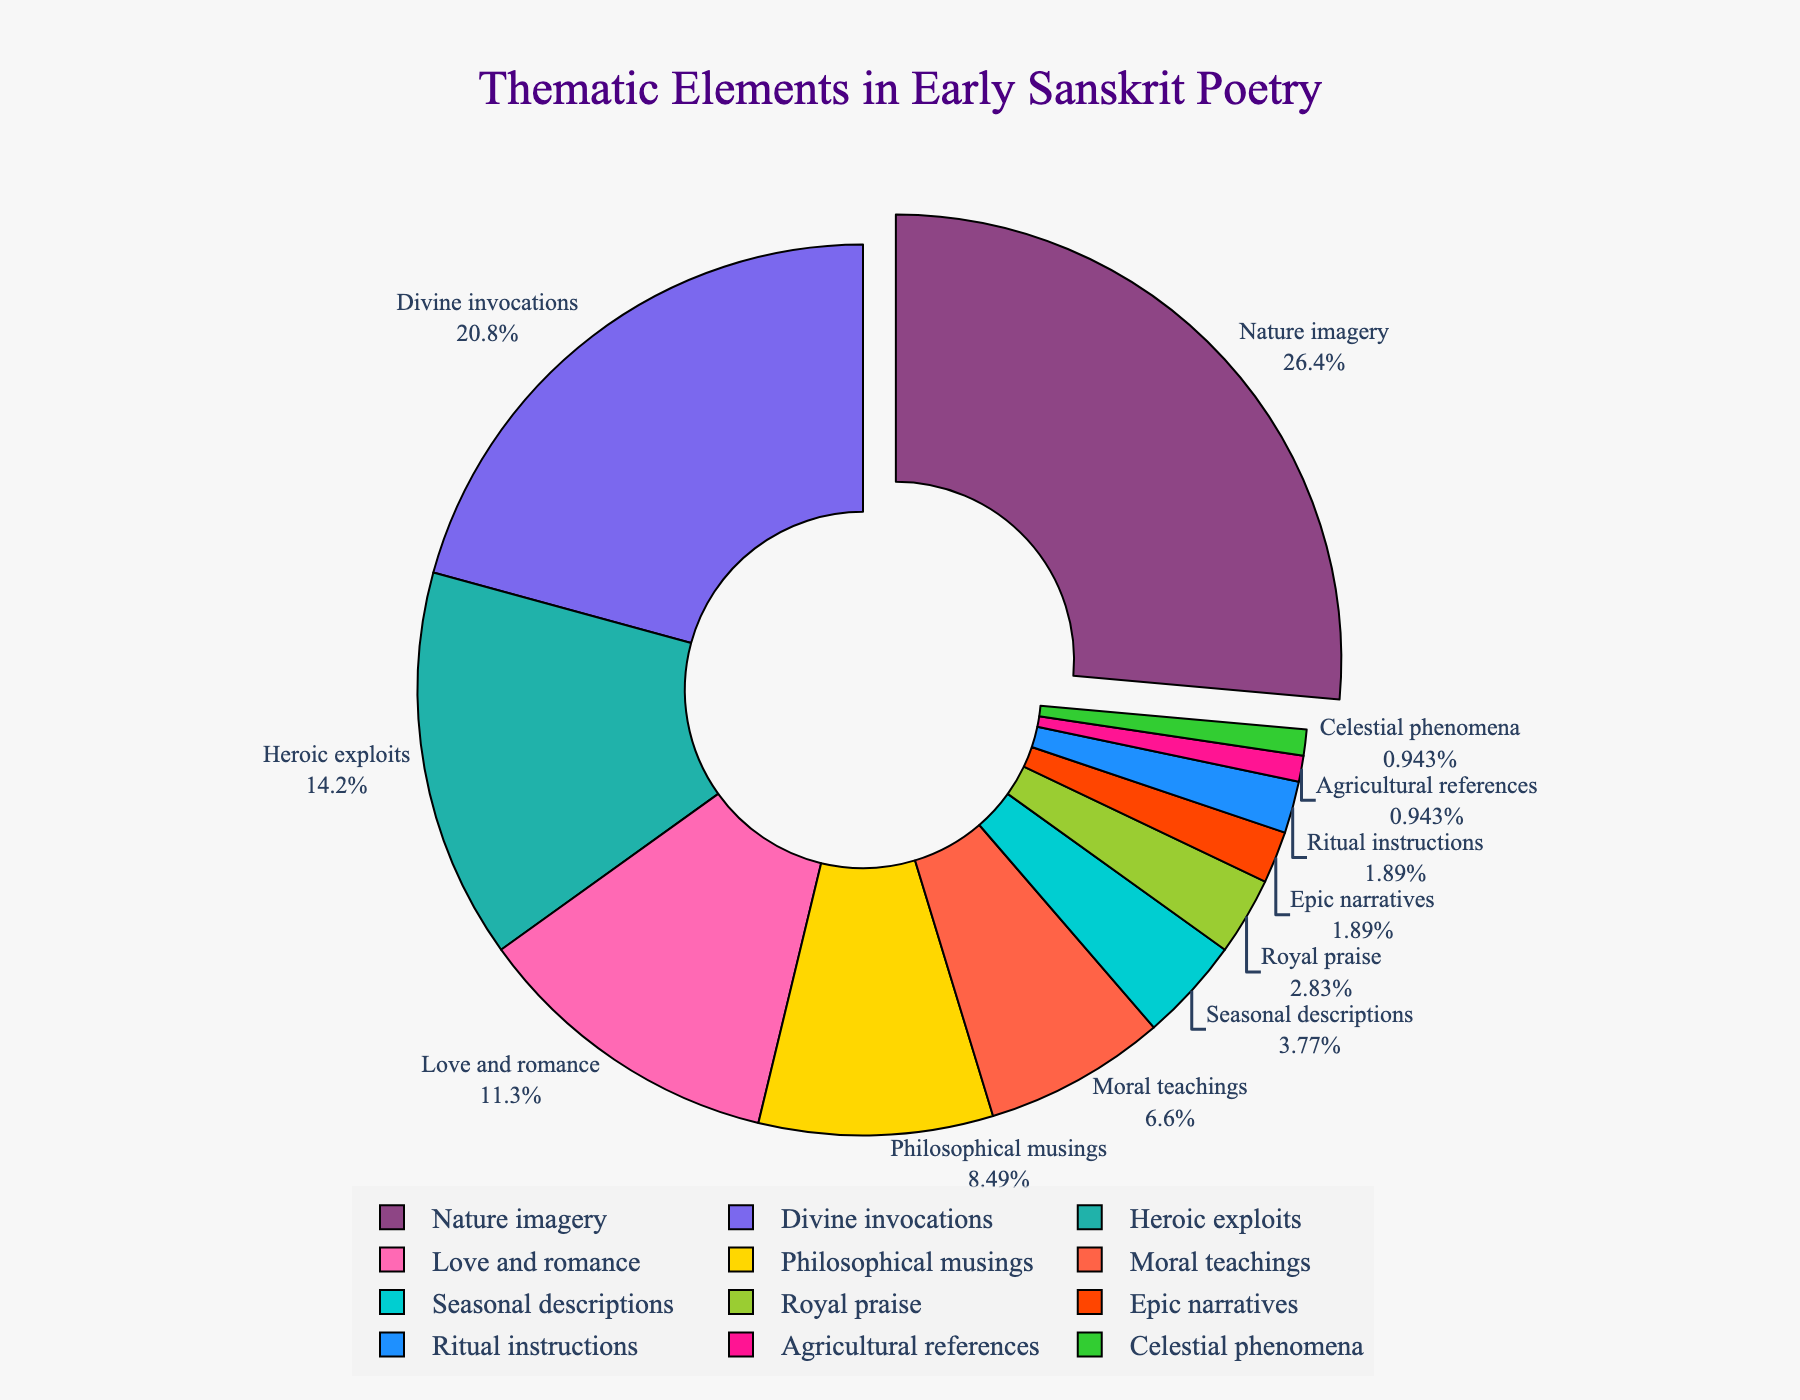What is the most frequently occurring theme in early Sanskrit poetry? The chart shows the thematic elements in early Sanskrit poetry by percentage. By looking at the largest segment, we can identify the most frequently occurring theme. Nature imagery has the largest segment at 28%.
Answer: Nature imagery What is the combined percentage of Divine invocations and Heroic exploits themes? To determine the combined percentage, add the percentages of Divine invocations (22%) and Heroic exploits (15%). Therefore, 22% + 15% = 37%.
Answer: 37% Which theme is represented by the smallest slice in the pie chart? The chart visually represents each thematic element. The smallest slice represents the themes of Agricultural references and Celestial phenomena, each at 1%.
Answer: Agricultural references and Celestial phenomena How much larger is the percentage of Love and romance compared to Royal praise? Compare their percentages: Love and romance is 12%, and Royal praise is 3%. To find how much larger Love and romance is, subtract the percentage of Royal praise from Love and romance: 12% - 3% = 9%.
Answer: 9% What is the difference in percentage between Moral teachings and Philosophical musings? Compare their percentages: Philosophical musings (9%) and Moral teachings (7%). The difference can be calculated as 9% - 7% = 2%.
Answer: 2% Which themes occupy less than 5% of the pie chart individually? The themes with less than 5% are those represented by smaller slices: Seasonal descriptions (4%), Royal praise (3%), Epic narratives (2%), Ritual instructions (2%), Agricultural references (1%), and Celestial phenomena (1%).
Answer: Seasonal descriptions, Royal praise, Epic narratives, Ritual instructions, Agricultural references, Celestial phenomena What is the visual significance of Nature imagery in the chart? In the pie chart, Nature imagery is visually emphasized by being pulled out more than the other slices, indicating its importance and the highest percentage (28%).
Answer: It is the largest and pulled out slice How does the percentage of Heroic exploits compare to Love and romance? Heroic exploits has a percentage of 15%, while Love and romance has 12%. Therefore, Heroic exploits has a higher percentage than Love and romance.
Answer: Heroic exploits is higher Which theme is represented by the color green in the diagram? The pie chart utilizes different colors for different themes. The green segment corresponds to the theme of Agricultural references, which has a percentage of 1%.
Answer: Agricultural references What is the average percentage of Divine invocations, Heroic exploits, and Moral teachings combined? To find the average percentage, sum the percentages of the themes and divide by the number of themes. (22% + 15% + 7%)/3 = 44%/3 ≈ 14.67%.
Answer: 14.67% 